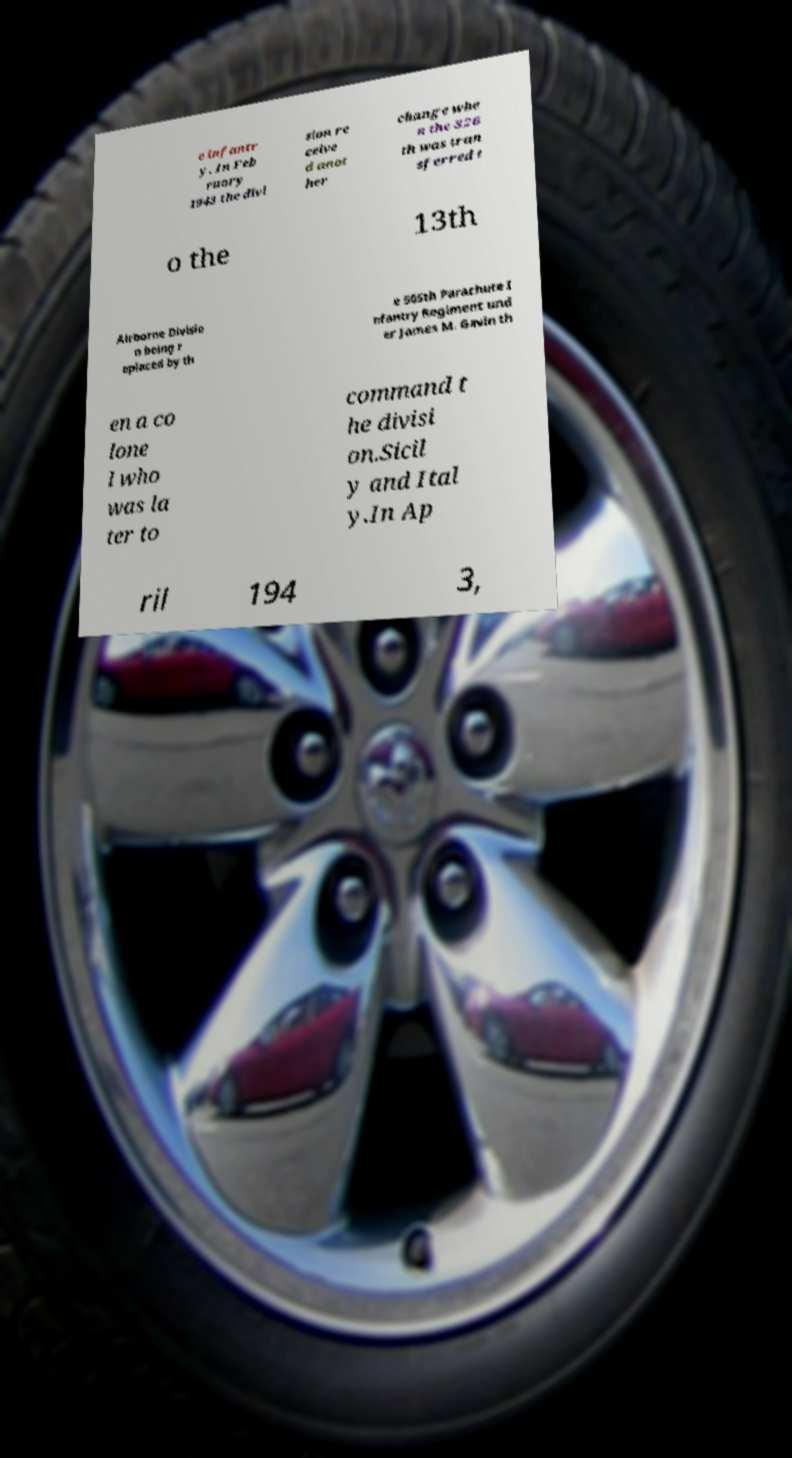For documentation purposes, I need the text within this image transcribed. Could you provide that? e infantr y. In Feb ruary 1943 the divi sion re ceive d anot her change whe n the 326 th was tran sferred t o the 13th Airborne Divisio n being r eplaced by th e 505th Parachute I nfantry Regiment und er James M. Gavin th en a co lone l who was la ter to command t he divisi on.Sicil y and Ital y.In Ap ril 194 3, 